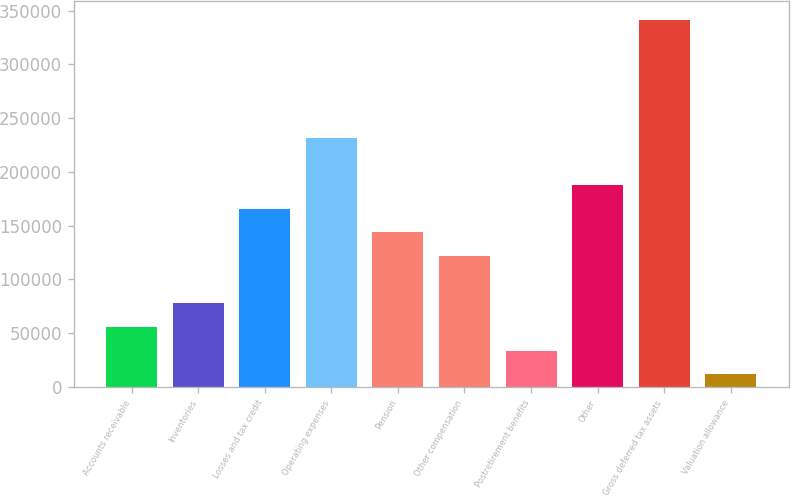Convert chart. <chart><loc_0><loc_0><loc_500><loc_500><bar_chart><fcel>Accounts receivable<fcel>Inventories<fcel>Losses and tax credit<fcel>Operating expenses<fcel>Pension<fcel>Other compensation<fcel>Postretirement benefits<fcel>Other<fcel>Gross deferred tax assets<fcel>Valuation allowance<nl><fcel>55717<fcel>77698<fcel>165622<fcel>231565<fcel>143641<fcel>121660<fcel>33736<fcel>187603<fcel>341470<fcel>11755<nl></chart> 